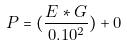Convert formula to latex. <formula><loc_0><loc_0><loc_500><loc_500>P = ( \frac { E * G } { 0 . 1 0 ^ { 2 } } ) + 0</formula> 